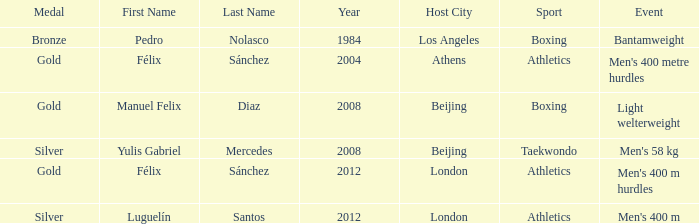What medal carried the name of manuel felix diaz? Gold. 